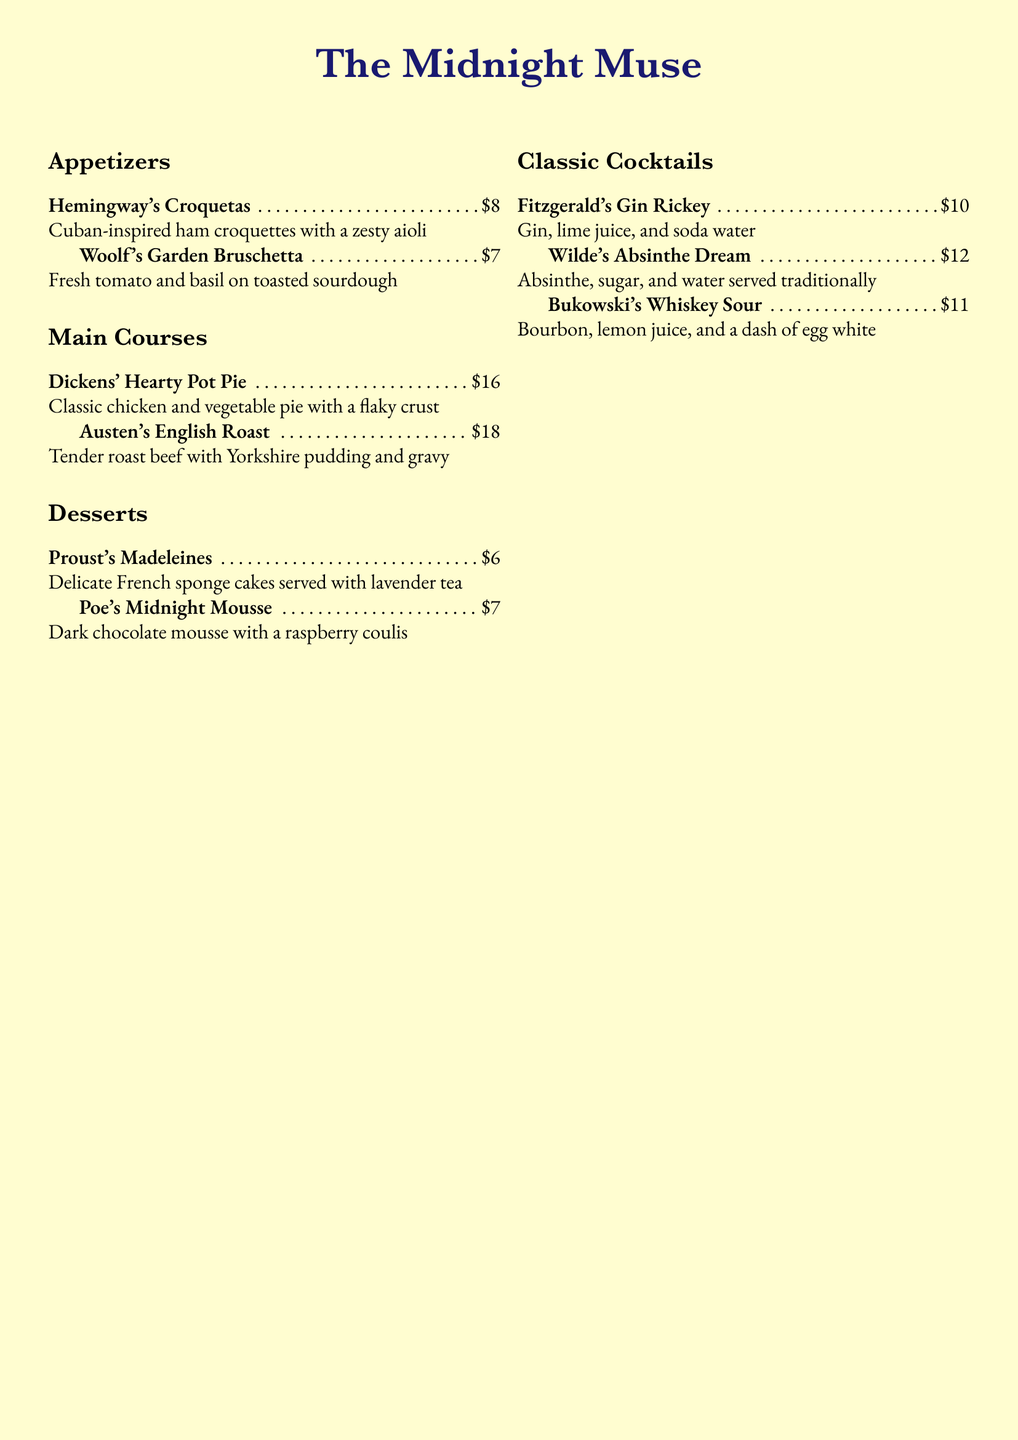What is the name of the restaurant? The name is prominently displayed at the top of the menu.
Answer: The Midnight Muse How much is Hemingway's Croquetas? The price is indicated next to the appetizer's name.
Answer: $8 What type of cake is served with Proust's Madeleines? The description specifies the type of cake in the dessert section.
Answer: French sponge cakes Which drink contains bourbon? The cocktail menu lists various ingredients for each drink, including the specific alcohol for Bukowski's drink.
Answer: Bukowski's Whiskey Sour What is featured as a special feature of the restaurant? The special feature is mentioned in the ambiance section at the bottom of the document.
Answer: Late-night writing sessions with complimentary coffee refills How many main courses are listed on the menu? The main course section includes two distinct items.
Answer: 2 What ingredients are in Wilde's Absinthe Dream? The ingredients for the cocktail are listed in the document.
Answer: Absinthe, sugar, and water What ambiance can diners expect at The Midnight Muse? The ambiance is described in a small note at the bottom of the menu.
Answer: Cozy reading nooks, vintage typewriters, and shelves of classic books 